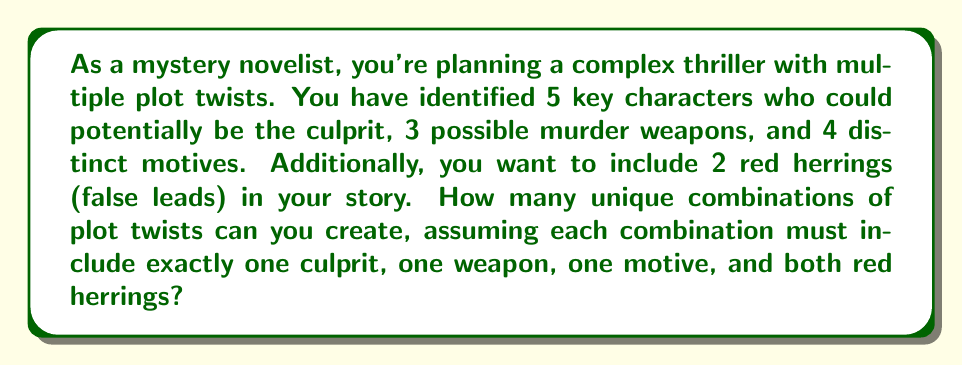Provide a solution to this math problem. Let's break this down step-by-step:

1) First, we need to choose the culprit. There are 5 possible choices for this.

2) Next, we need to select the murder weapon. There are 3 options available.

3) Then, we need to decide on the motive. We have 4 choices for this.

4) Finally, we need to include both red herrings. However, since both must be included, there's only one way to do this.

5) To find the total number of unique combinations, we use the multiplication principle of counting. We multiply the number of choices for each decision:

   $$ 5 \times 3 \times 4 \times 1 = 60 $$

6) Therefore, the total number of unique plot twist combinations is 60.

This calculation can be represented using the formula:

$$ \text{Total Combinations} = n_{\text{culprits}} \times n_{\text{weapons}} \times n_{\text{motives}} \times n_{\text{red herring combinations}} $$

Where $n$ represents the number of choices for each category.
Answer: 60 combinations 